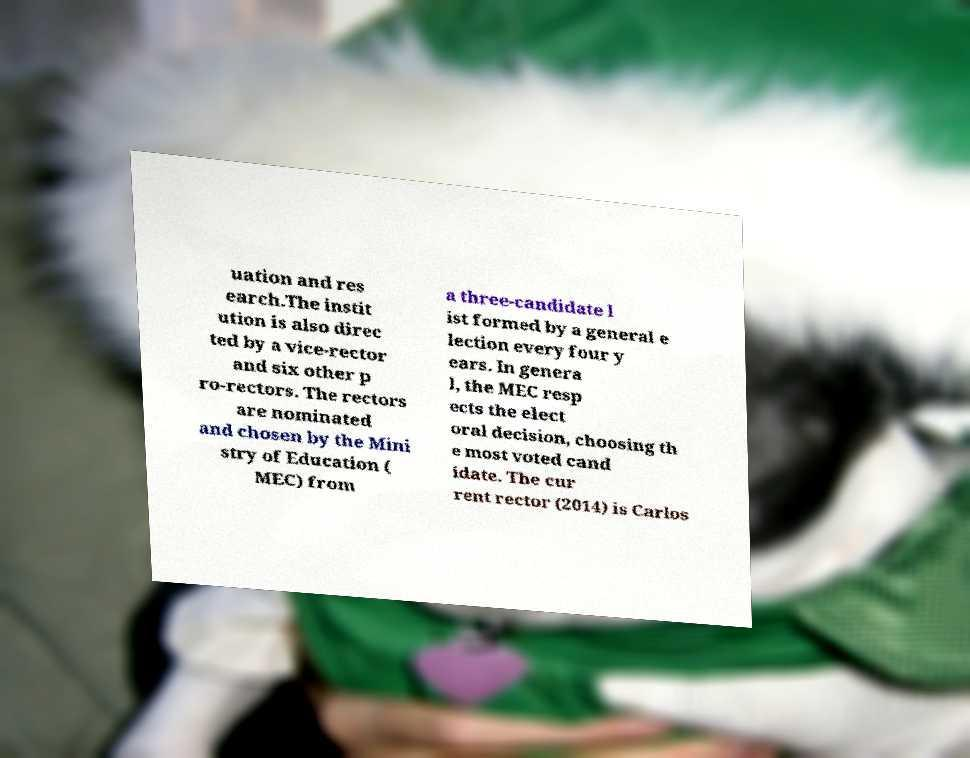Could you assist in decoding the text presented in this image and type it out clearly? uation and res earch.The instit ution is also direc ted by a vice-rector and six other p ro-rectors. The rectors are nominated and chosen by the Mini stry of Education ( MEC) from a three-candidate l ist formed by a general e lection every four y ears. In genera l, the MEC resp ects the elect oral decision, choosing th e most voted cand idate. The cur rent rector (2014) is Carlos 